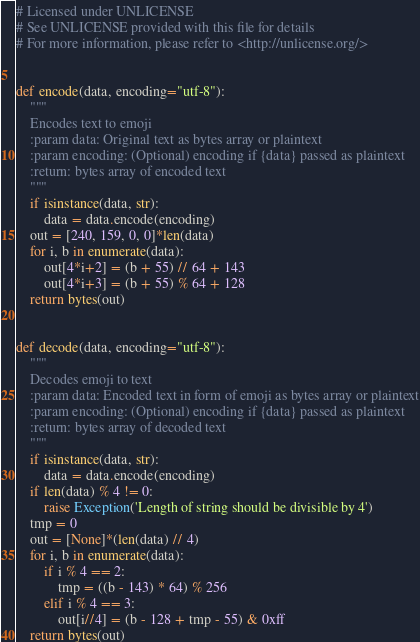<code> <loc_0><loc_0><loc_500><loc_500><_Python_># Licensed under UNLICENSE
# See UNLICENSE provided with this file for details
# For more information, please refer to <http://unlicense.org/>


def encode(data, encoding="utf-8"):
    """
    Encodes text to emoji
    :param data: Original text as bytes array or plaintext
    :param encoding: (Optional) encoding if {data} passed as plaintext
    :return: bytes array of encoded text
    """
    if isinstance(data, str):
        data = data.encode(encoding)
    out = [240, 159, 0, 0]*len(data)
    for i, b in enumerate(data):
        out[4*i+2] = (b + 55) // 64 + 143
        out[4*i+3] = (b + 55) % 64 + 128
    return bytes(out)


def decode(data, encoding="utf-8"):
    """
    Decodes emoji to text
    :param data: Encoded text in form of emoji as bytes array or plaintext
    :param encoding: (Optional) encoding if {data} passed as plaintext
    :return: bytes array of decoded text
    """
    if isinstance(data, str):
        data = data.encode(encoding)
    if len(data) % 4 != 0:
        raise Exception('Length of string should be divisible by 4')
    tmp = 0
    out = [None]*(len(data) // 4)
    for i, b in enumerate(data):
        if i % 4 == 2:
            tmp = ((b - 143) * 64) % 256
        elif i % 4 == 3:
            out[i//4] = (b - 128 + tmp - 55) & 0xff
    return bytes(out)

</code> 